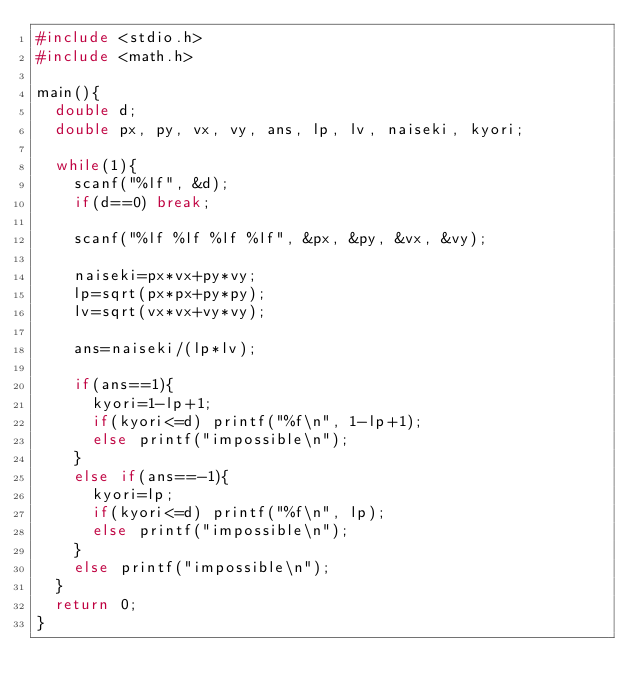Convert code to text. <code><loc_0><loc_0><loc_500><loc_500><_C_>#include <stdio.h>
#include <math.h>

main(){
  double d;
  double px, py, vx, vy, ans, lp, lv, naiseki, kyori;

  while(1){
    scanf("%lf", &d);
    if(d==0) break;

    scanf("%lf %lf %lf %lf", &px, &py, &vx, &vy);

    naiseki=px*vx+py*vy;
    lp=sqrt(px*px+py*py);
    lv=sqrt(vx*vx+vy*vy);

    ans=naiseki/(lp*lv);

    if(ans==1){
      kyori=1-lp+1;
      if(kyori<=d) printf("%f\n", 1-lp+1);
      else printf("impossible\n");
    }
    else if(ans==-1){
      kyori=lp;
      if(kyori<=d) printf("%f\n", lp);
      else printf("impossible\n");
    }
    else printf("impossible\n");
  }
  return 0;
}</code> 